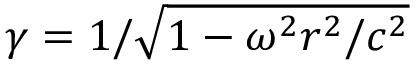Convert formula to latex. <formula><loc_0><loc_0><loc_500><loc_500>\gamma = 1 / \sqrt { 1 - \omega ^ { 2 } r ^ { 2 } / c ^ { 2 } }</formula> 